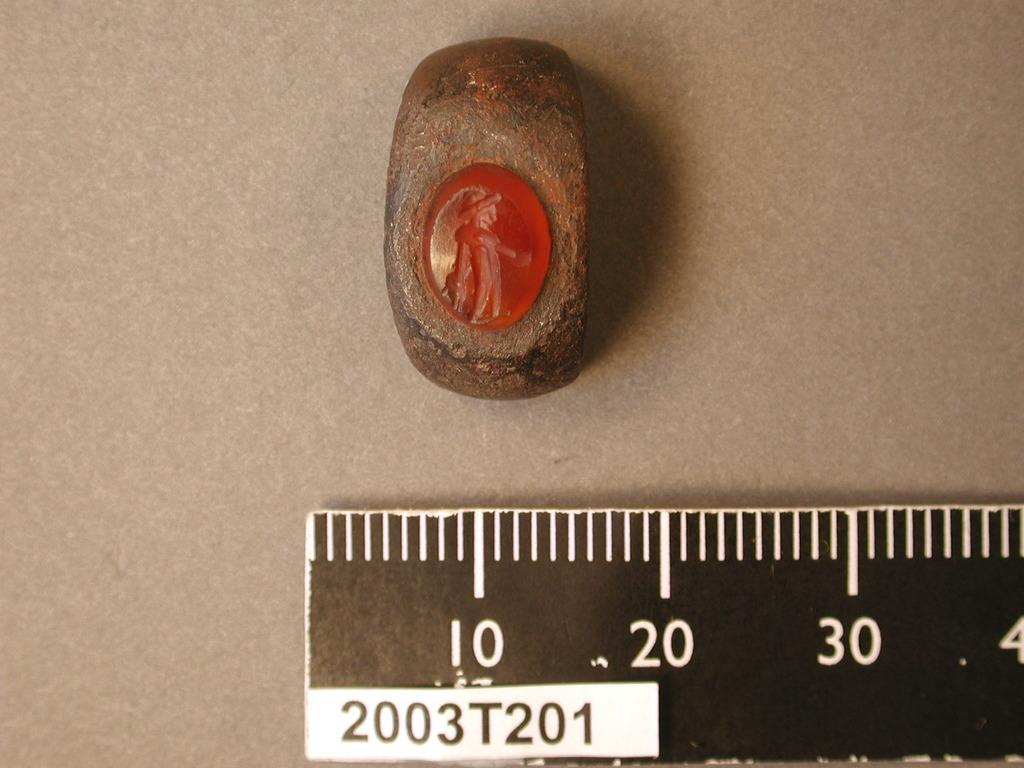<image>
Write a terse but informative summary of the picture. the number ten is on the black and white ruler 